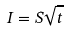<formula> <loc_0><loc_0><loc_500><loc_500>I = S \sqrt { t }</formula> 